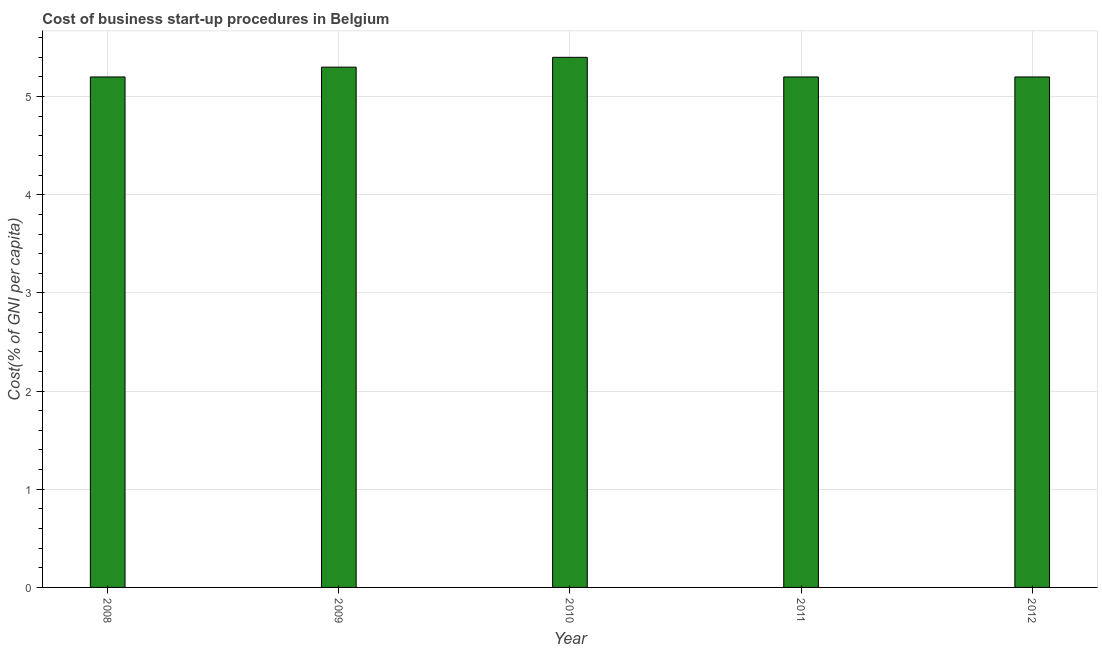Does the graph contain grids?
Your response must be concise. Yes. What is the title of the graph?
Keep it short and to the point. Cost of business start-up procedures in Belgium. What is the label or title of the Y-axis?
Give a very brief answer. Cost(% of GNI per capita). Across all years, what is the maximum cost of business startup procedures?
Your response must be concise. 5.4. Across all years, what is the minimum cost of business startup procedures?
Offer a very short reply. 5.2. What is the sum of the cost of business startup procedures?
Give a very brief answer. 26.3. What is the difference between the cost of business startup procedures in 2008 and 2009?
Offer a terse response. -0.1. What is the average cost of business startup procedures per year?
Offer a very short reply. 5.26. What is the median cost of business startup procedures?
Offer a terse response. 5.2. Do a majority of the years between 2009 and 2011 (inclusive) have cost of business startup procedures greater than 3.6 %?
Offer a terse response. Yes. Is the cost of business startup procedures in 2011 less than that in 2012?
Your answer should be very brief. No. Is the difference between the cost of business startup procedures in 2008 and 2010 greater than the difference between any two years?
Offer a terse response. Yes. What is the difference between the highest and the second highest cost of business startup procedures?
Your answer should be compact. 0.1. What is the difference between the highest and the lowest cost of business startup procedures?
Ensure brevity in your answer.  0.2. In how many years, is the cost of business startup procedures greater than the average cost of business startup procedures taken over all years?
Offer a terse response. 2. Are all the bars in the graph horizontal?
Offer a terse response. No. What is the Cost(% of GNI per capita) in 2008?
Offer a very short reply. 5.2. What is the Cost(% of GNI per capita) of 2010?
Provide a short and direct response. 5.4. What is the Cost(% of GNI per capita) in 2011?
Provide a short and direct response. 5.2. What is the Cost(% of GNI per capita) in 2012?
Make the answer very short. 5.2. What is the difference between the Cost(% of GNI per capita) in 2008 and 2009?
Provide a succinct answer. -0.1. What is the difference between the Cost(% of GNI per capita) in 2008 and 2011?
Provide a succinct answer. 0. What is the difference between the Cost(% of GNI per capita) in 2008 and 2012?
Your response must be concise. 0. What is the difference between the Cost(% of GNI per capita) in 2009 and 2010?
Offer a terse response. -0.1. What is the difference between the Cost(% of GNI per capita) in 2009 and 2012?
Offer a very short reply. 0.1. What is the difference between the Cost(% of GNI per capita) in 2010 and 2011?
Your response must be concise. 0.2. What is the difference between the Cost(% of GNI per capita) in 2010 and 2012?
Your answer should be very brief. 0.2. What is the difference between the Cost(% of GNI per capita) in 2011 and 2012?
Ensure brevity in your answer.  0. What is the ratio of the Cost(% of GNI per capita) in 2008 to that in 2010?
Your response must be concise. 0.96. What is the ratio of the Cost(% of GNI per capita) in 2008 to that in 2011?
Your answer should be compact. 1. What is the ratio of the Cost(% of GNI per capita) in 2008 to that in 2012?
Ensure brevity in your answer.  1. What is the ratio of the Cost(% of GNI per capita) in 2009 to that in 2012?
Your answer should be very brief. 1.02. What is the ratio of the Cost(% of GNI per capita) in 2010 to that in 2011?
Your response must be concise. 1.04. What is the ratio of the Cost(% of GNI per capita) in 2010 to that in 2012?
Your answer should be very brief. 1.04. 